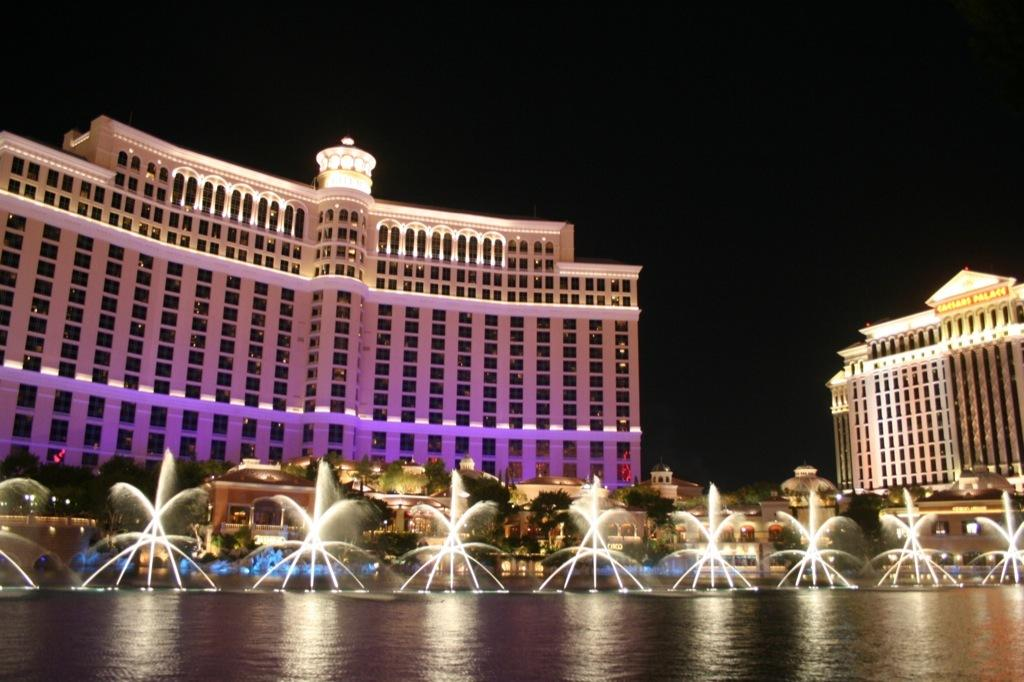What can be seen in the background of the image? There are buildings and trees in the background of the image. What is the main feature in the center of the image? There is a water fountain in the center of the image. What is visible at the bottom of the image? There is water visible at the bottom of the image. What is the weight of the father in the image? There is no father present in the image, so it is not possible to determine their weight. 